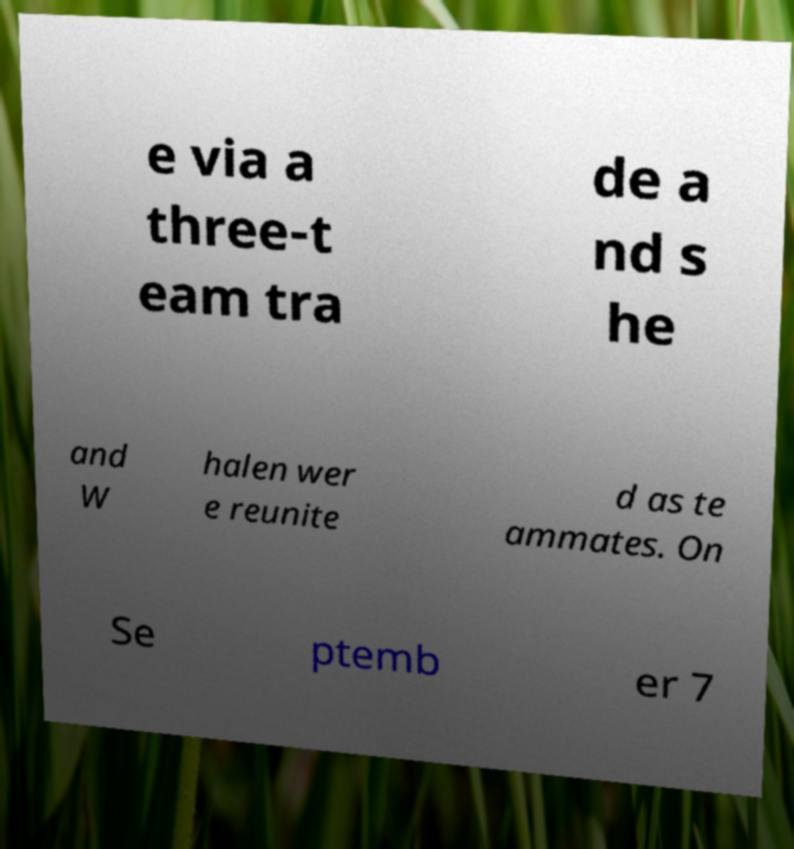Please read and relay the text visible in this image. What does it say? e via a three-t eam tra de a nd s he and W halen wer e reunite d as te ammates. On Se ptemb er 7 